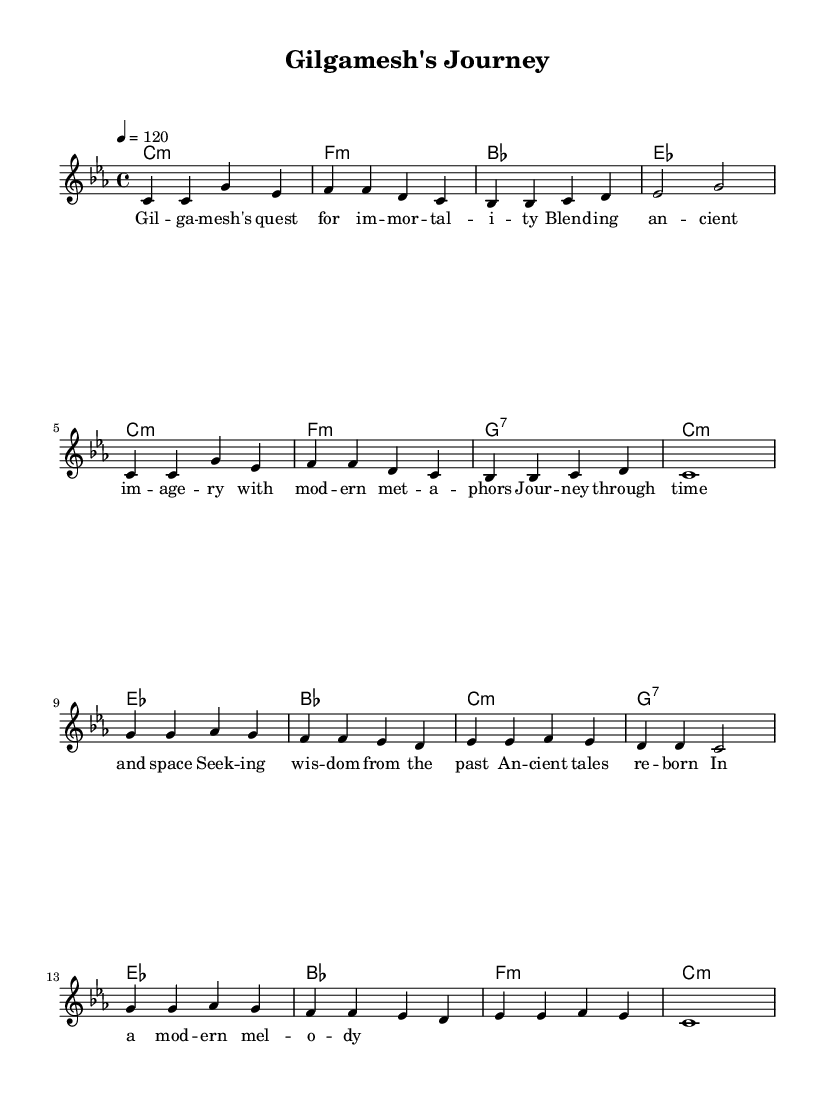What is the key signature of this music? The key signature is C minor, which has three flats (B-flat, E-flat, and A-flat). It is indicated at the beginning of the sheet music.
Answer: C minor What is the time signature of this music? The time signature is 4/4, which means there are four beats in each measure and the quarter note gets one beat. This is shown at the beginning of the score.
Answer: 4/4 What is the tempo indicated in this score? The score indicates a tempo marking of 120 beats per minute, which is typically denoted by a number at the beginning of the music and provides a guide for the speed of the performance.
Answer: 120 How many measures are there in the verse section? The verse section consists of two repeated phrases, each containing four measures, resulting in a total of eight measures for the verse.
Answer: Eight What is the primary theme of the lyrics? The lyrics describe Gilgamesh's quest for immortality, combining ancient imagery with modern metaphors, showcasing a journey through time and wisdom gathering. This is inferred from the content of the lyrics provided under the melody.
Answer: Immortality What chord follows the G7 chord in the chorus? In the chorus, the chord progression shows that after a G7 chord, an E-flat major chord is played, which can be traced in the sequence of harmonies under the chorus section.
Answer: E-flat How are modern elements incorporated into the music? Modern elements are incorporated through the use of contemporary lyrical themes and structures that relate ancient Sumerian legends to modern motifs, reflecting a blend of past and present styles in the song. This interpretation can be deduced from the content in the lyrics and overall style of the piece.
Answer: Contemporary lyrics 